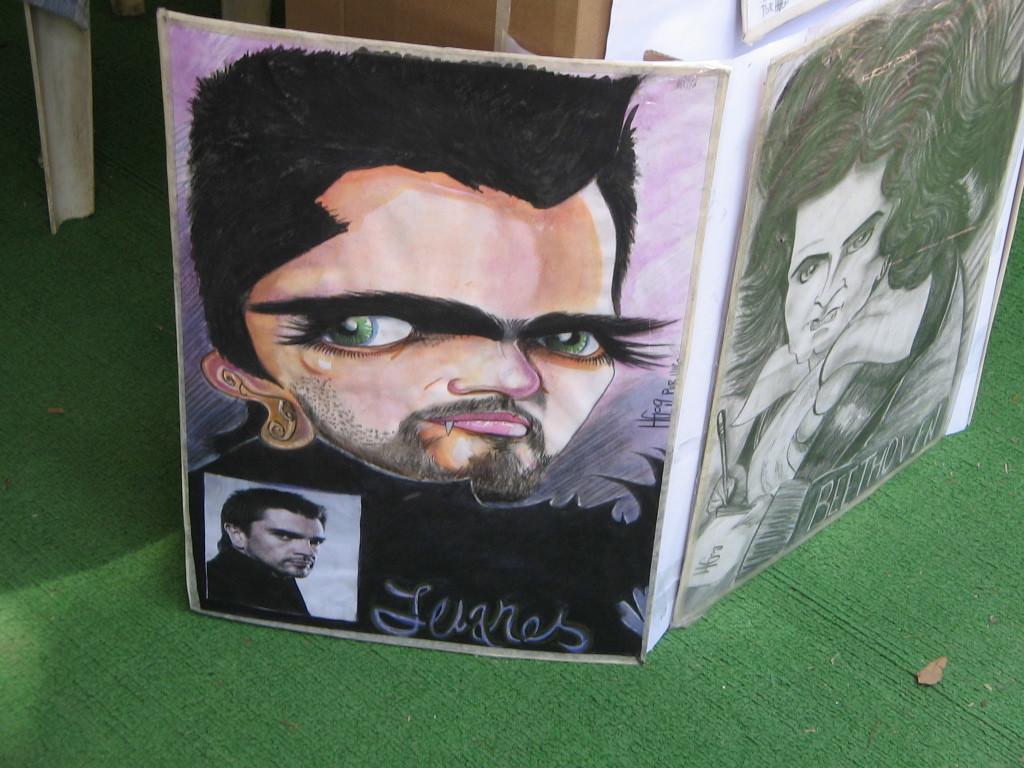Describe this image in one or two sentences. In this picture I can see a board on which there is some painting. 